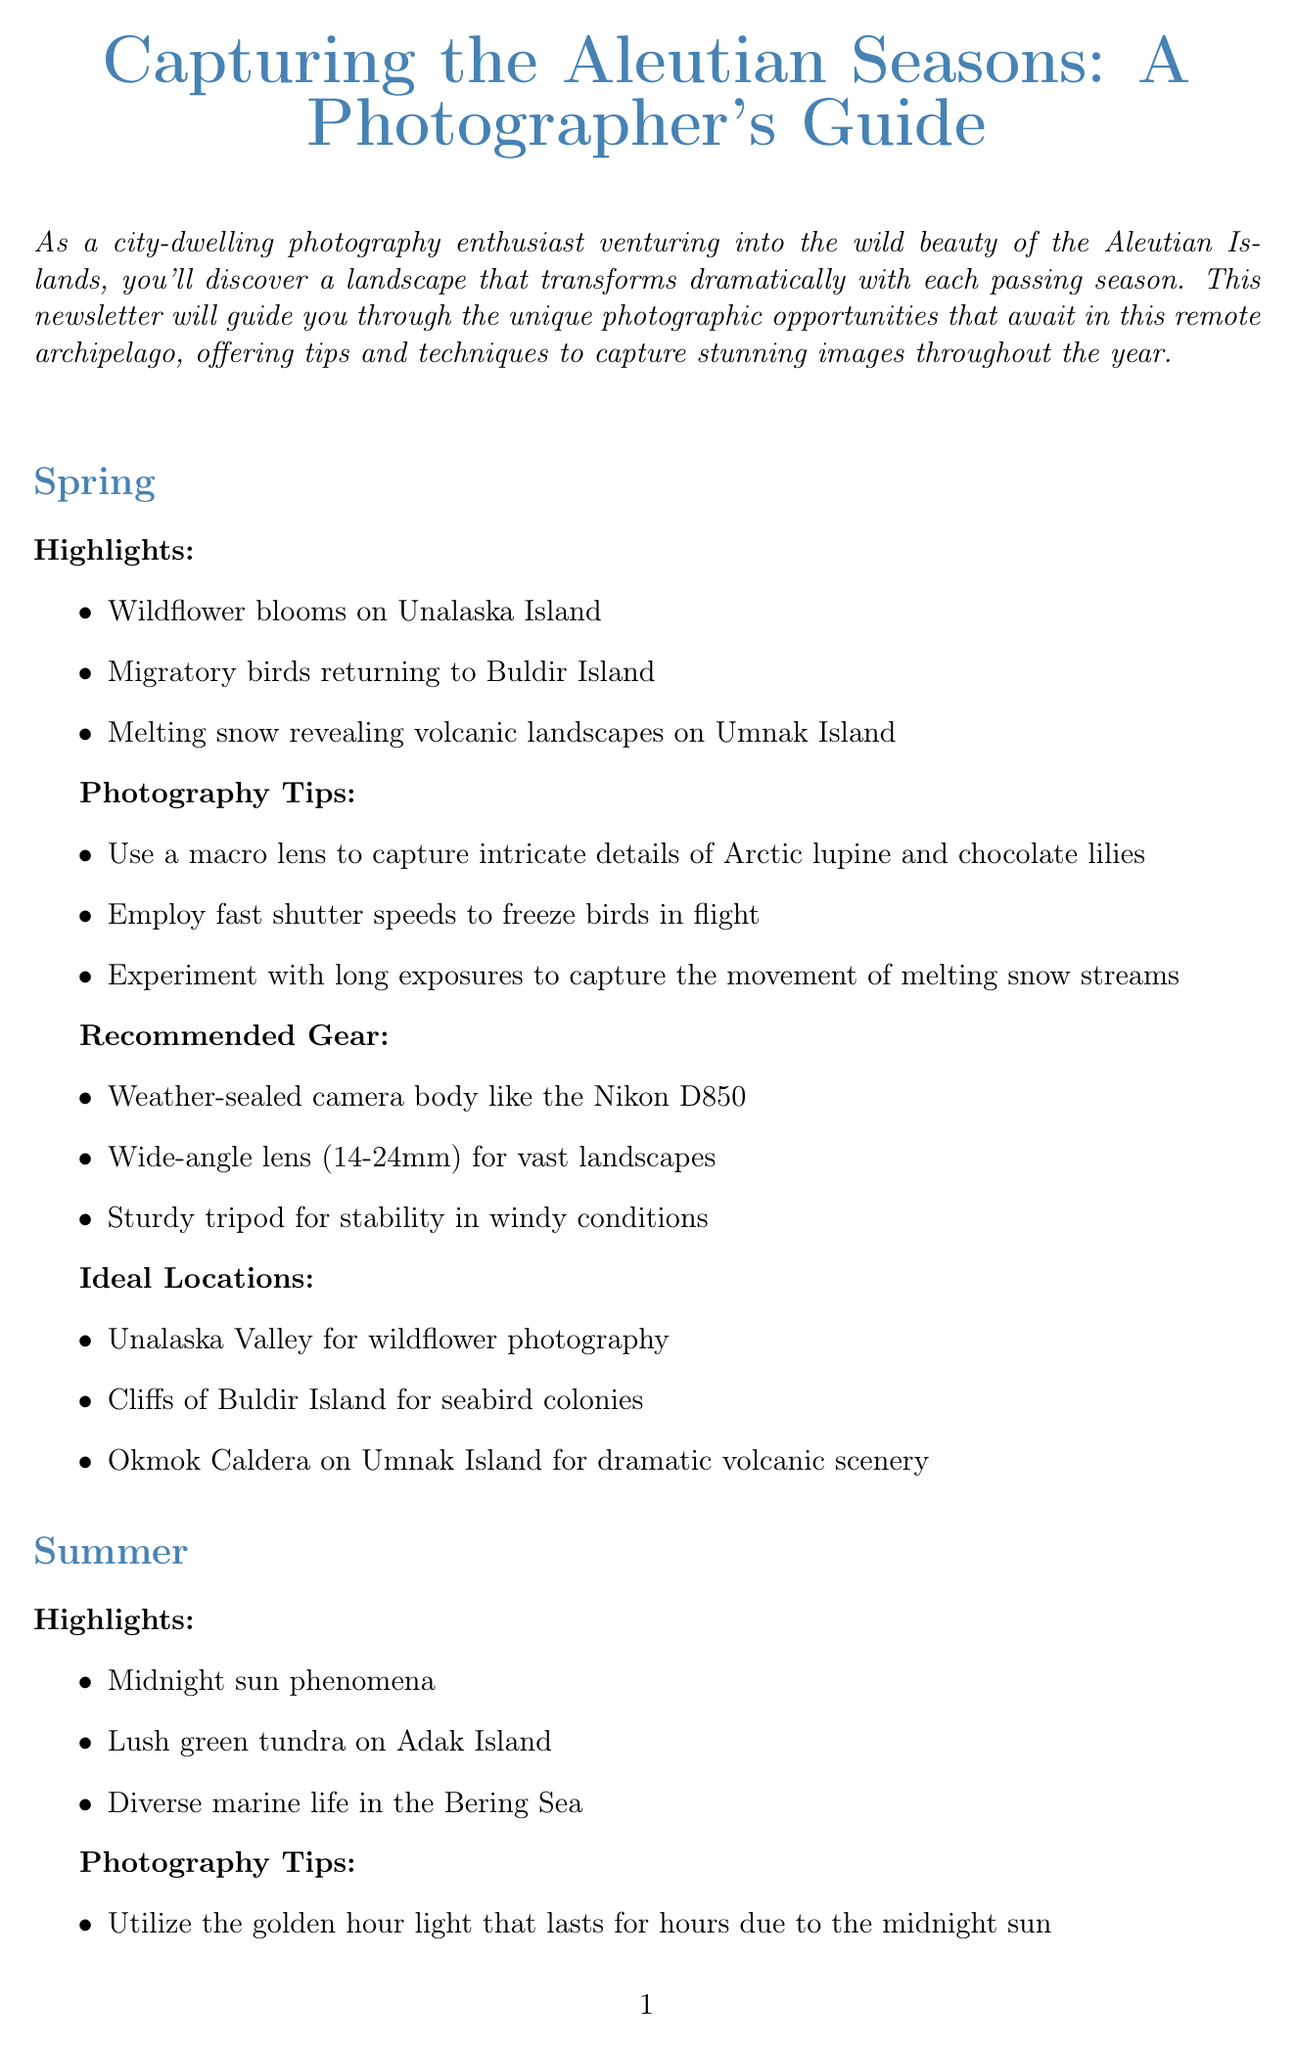what are the highlights of spring? The highlights of spring include wildflower blooms on Unalaska Island, migratory birds returning to Buldir Island, and melting snow revealing volcanic landscapes on Umnak Island.
Answer: wildflower blooms on Unalaska Island, migratory birds returning to Buldir Island, melting snow revealing volcanic landscapes on Umnak Island which camera is recommended for autumn photography? The document recommends the Canon EOS R5 for its excellent low-light performance in autumn photography.
Answer: Canon EOS R5 how should one photograph the Northern Lights? To photograph the Northern Lights, one should employ long exposures and high ISO settings.
Answer: long exposures and high ISO what is an ideal location for summer photography? An ideal location for summer photography is Mount Moffett on Adak Island for panoramic views.
Answer: Mount Moffett on Adak Island what equipment is advised to carry in winter conditions? The document advises carrying extreme cold weather camera covers and extra batteries kept warm in inner pockets for winter photography.
Answer: extreme cold weather camera covers, extra batteries how do the photography tips vary across seasons? The photography tips vary by focusing on specific techniques that suit each season's characteristics, such as macro lenses in spring and underwater photography in summer.
Answer: specific techniques per season where can one find information on transportation in the Aleutians? Information on transportation in the Aleutians can be found under the Additional Resources section.
Answer: Additional Resources section which lens is suggested for capturing wildlife in summer? A telephoto lens (100-400mm) is suggested for wildlife photography during summer.
Answer: telephoto lens (100-400mm) 